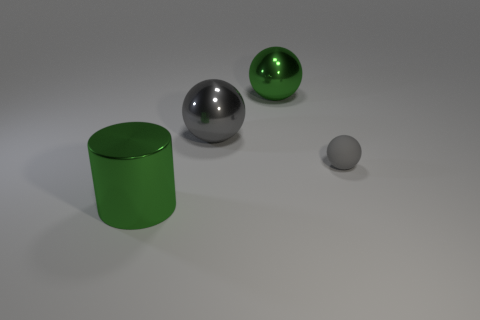Are there any other green objects that have the same size as the matte object?
Your response must be concise. No. What number of things are gray balls left of the small gray thing or big green things that are behind the rubber sphere?
Your answer should be very brief. 2. There is a green metallic thing that is the same size as the cylinder; what shape is it?
Give a very brief answer. Sphere. Is there a big gray thing of the same shape as the small gray rubber thing?
Offer a terse response. Yes. Is the number of big shiny spheres less than the number of metallic things?
Give a very brief answer. Yes. Do the green thing right of the big green metal cylinder and the object right of the green metal ball have the same size?
Offer a terse response. No. How many objects are metal balls or gray metallic objects?
Keep it short and to the point. 2. There is a green shiny thing that is on the right side of the large green metallic cylinder; what size is it?
Offer a terse response. Large. What number of big green spheres are to the right of the large object in front of the gray object that is in front of the gray metallic object?
Offer a very short reply. 1. Do the metallic cylinder and the rubber ball have the same color?
Your answer should be very brief. No. 